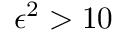Convert formula to latex. <formula><loc_0><loc_0><loc_500><loc_500>\epsilon ^ { 2 } > 1 0 \</formula> 